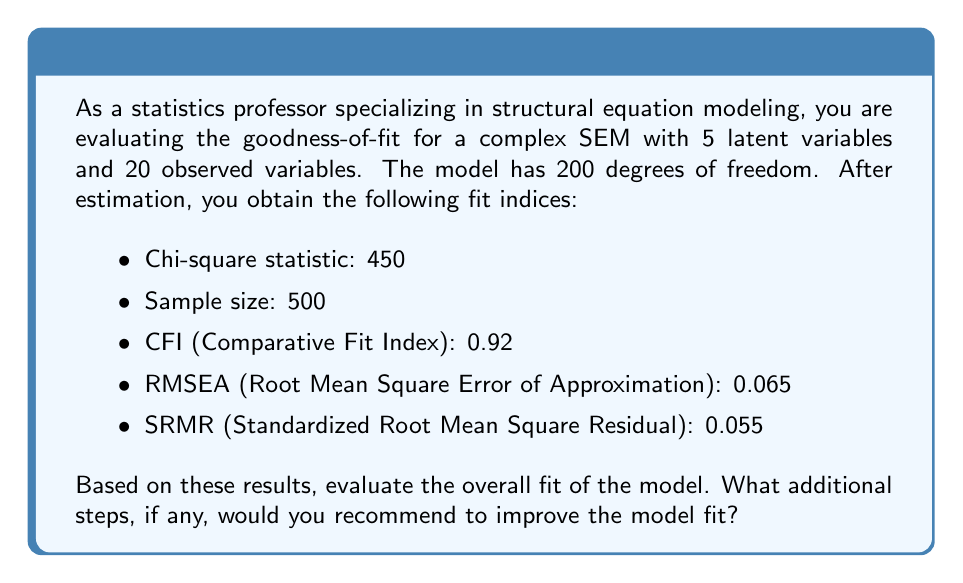Help me with this question. To evaluate the goodness-of-fit for this complex structural equation model, we need to consider multiple fit indices simultaneously. Let's analyze each index:

1. Chi-square test:
The chi-square statistic is 450 with 200 degrees of freedom. We can calculate the chi-square to df ratio:

$$\frac{\chi^2}{df} = \frac{450}{200} = 2.25$$

Generally, a ratio below 3 is considered acceptable, with values closer to 1 indicating better fit. Our ratio of 2.25 suggests a reasonable fit.

2. CFI (Comparative Fit Index):
The CFI value is 0.92. CFI ranges from 0 to 1, with values above 0.90 indicating acceptable fit and values above 0.95 indicating good fit. Our CFI of 0.92 suggests an acceptable, but not excellent, fit.

3. RMSEA (Root Mean Square Error of Approximation):
The RMSEA value is 0.065. RMSEA values below 0.05 indicate good fit, values between 0.05 and 0.08 suggest reasonable fit, and values above 0.10 indicate poor fit. Our RMSEA of 0.065 falls in the reasonable fit range.

4. SRMR (Standardized Root Mean Square Residual):
The SRMR value is 0.055. SRMR values below 0.08 are generally considered good fit. Our SRMR of 0.055 indicates good fit.

Overall evaluation:
The model shows acceptable fit across multiple indices, but there is room for improvement. The CFI is slightly below the threshold for good fit, and the RMSEA is in the reasonable range but could be improved.

Additional steps to improve model fit:

1. Examine modification indices to identify potential misspecifications in the model. Look for large modification index values that make theoretical sense.

2. Inspect residual covariance matrices to identify local areas of misfit. Large standardized residuals (>|2.58|) may indicate problematic relationships.

3. Consider using bootstrapping methods to obtain more robust estimates of parameter standard errors and confidence intervals, which can help in assessing the stability of the model.

4. If theoretically justified, consider adding or removing paths based on the modification indices and your subject matter expertise.

5. Evaluate the measurement model separately from the structural model to ensure that the measurement part is adequate before assessing the structural relationships.

6. Consider alternative models that might better represent the underlying theory and compare their fit using information criteria (e.g., AIC, BIC) and chi-square difference tests for nested models.

7. Assess the impact of influential cases or outliers on model fit using case-wise diagnostics.

8. If sample size permits, consider cross-validation by splitting the sample and re-estimating the model on a holdout sample.
Answer: The model shows acceptable but not excellent fit. While the $\chi^2/df$ ratio (2.25) and SRMR (0.055) indicate good fit, the CFI (0.92) and RMSEA (0.065) suggest room for improvement. Additional steps, including examining modification indices, inspecting residual covariances, and considering theoretically justified model modifications, are recommended to enhance model fit. 